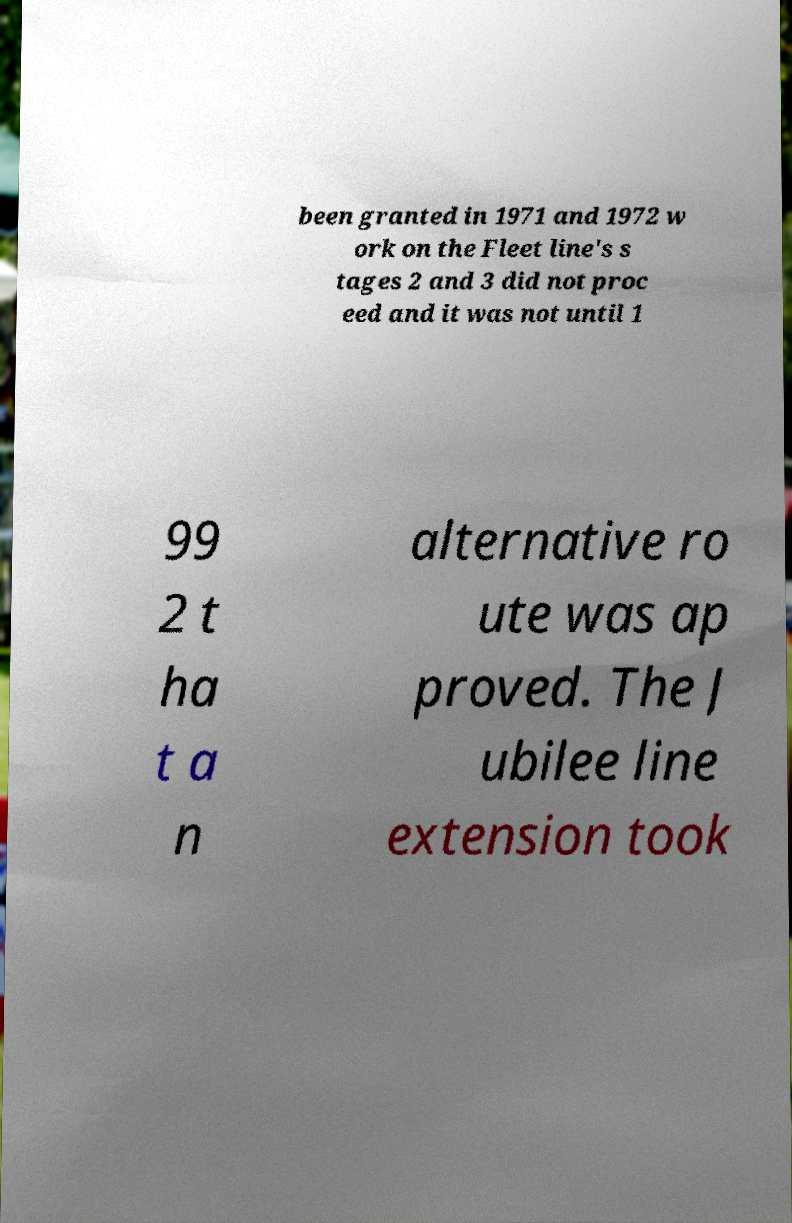There's text embedded in this image that I need extracted. Can you transcribe it verbatim? been granted in 1971 and 1972 w ork on the Fleet line's s tages 2 and 3 did not proc eed and it was not until 1 99 2 t ha t a n alternative ro ute was ap proved. The J ubilee line extension took 